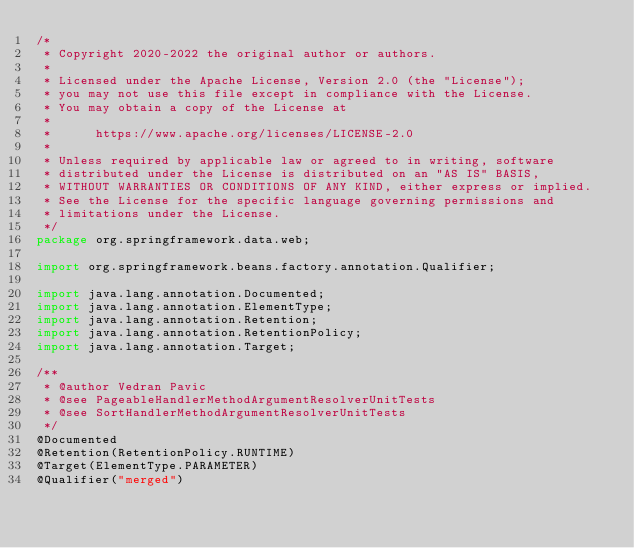Convert code to text. <code><loc_0><loc_0><loc_500><loc_500><_Java_>/*
 * Copyright 2020-2022 the original author or authors.
 *
 * Licensed under the Apache License, Version 2.0 (the "License");
 * you may not use this file except in compliance with the License.
 * You may obtain a copy of the License at
 *
 *      https://www.apache.org/licenses/LICENSE-2.0
 *
 * Unless required by applicable law or agreed to in writing, software
 * distributed under the License is distributed on an "AS IS" BASIS,
 * WITHOUT WARRANTIES OR CONDITIONS OF ANY KIND, either express or implied.
 * See the License for the specific language governing permissions and
 * limitations under the License.
 */
package org.springframework.data.web;

import org.springframework.beans.factory.annotation.Qualifier;

import java.lang.annotation.Documented;
import java.lang.annotation.ElementType;
import java.lang.annotation.Retention;
import java.lang.annotation.RetentionPolicy;
import java.lang.annotation.Target;

/**
 * @author Vedran Pavic
 * @see PageableHandlerMethodArgumentResolverUnitTests
 * @see SortHandlerMethodArgumentResolverUnitTests
 */
@Documented
@Retention(RetentionPolicy.RUNTIME)
@Target(ElementType.PARAMETER)
@Qualifier("merged")</code> 